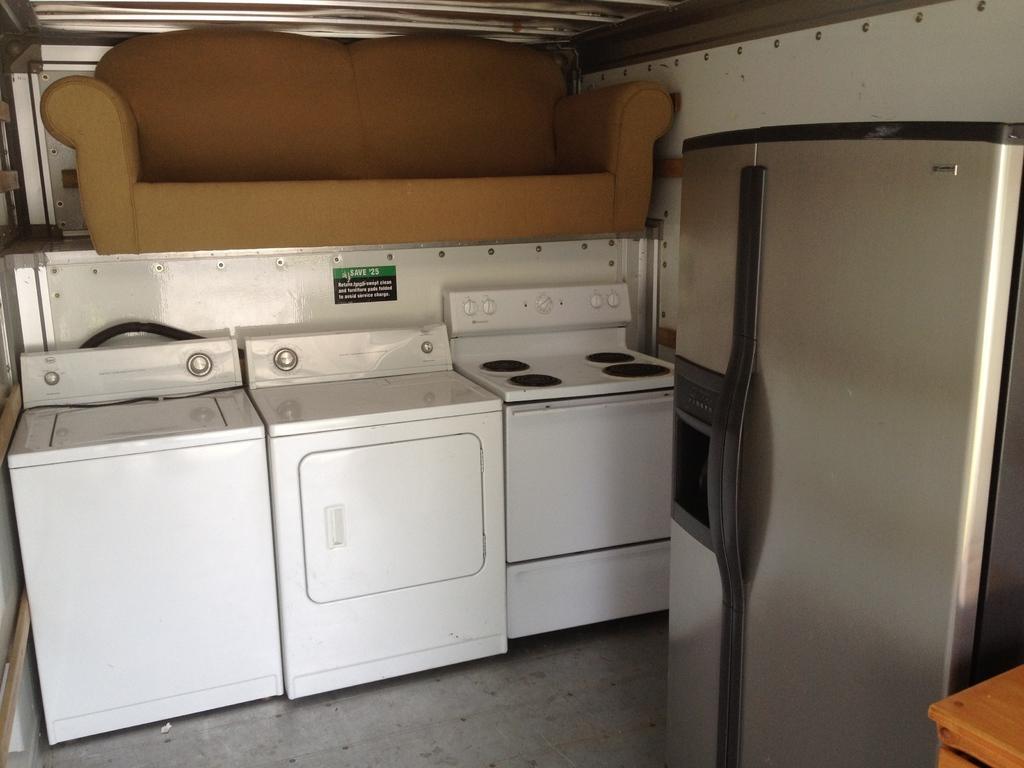How would you summarize this image in a sentence or two? In this picture we can able to see a washing machine, a dryer, a stove, on top of those there is a sofa and at right corner of the image we can able to see a refrigerator. 